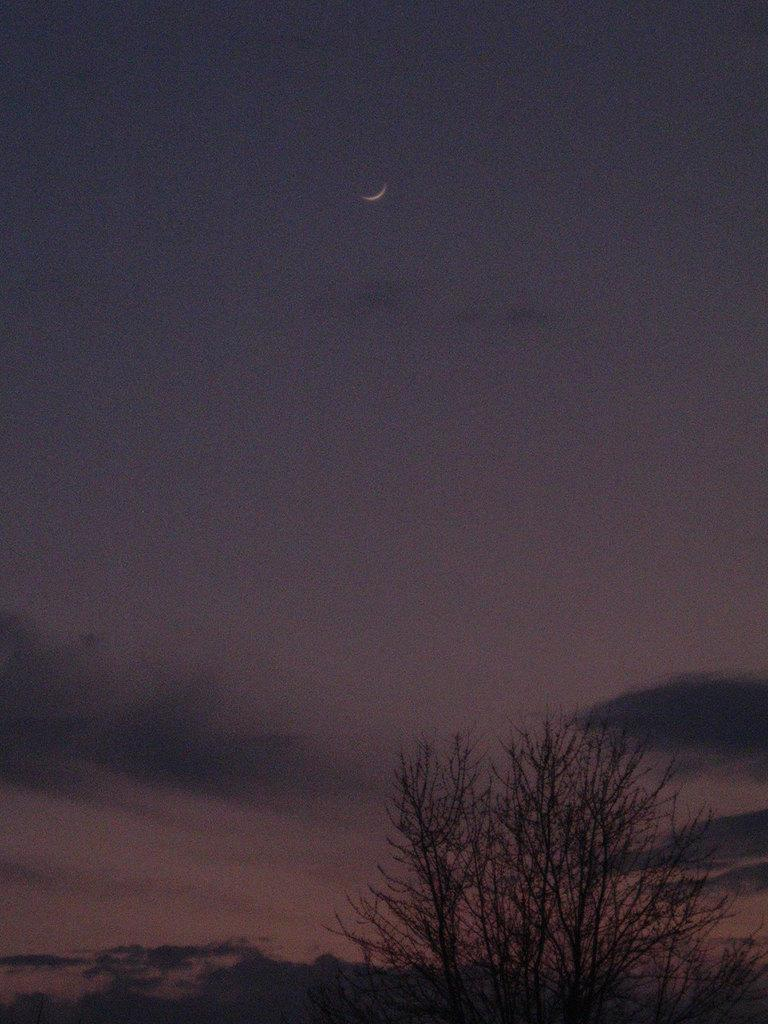What type of vegetation is present in the image? There is a tree in the image. What is the condition of the sky in the image? The sky is cloudy in the image. What celestial body can be seen in the image? The moon is visible in the image. What type of crate is being used to catch the frog in the image? There is no crate or frog present in the image. What type of pan is being used to cook the food in the image? There is no pan or food present in the image. 